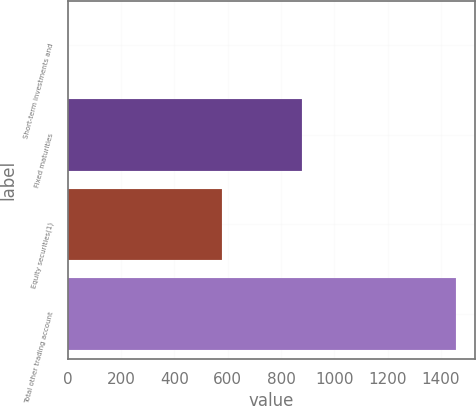<chart> <loc_0><loc_0><loc_500><loc_500><bar_chart><fcel>Short-term investments and<fcel>Fixed maturities<fcel>Equity securities(1)<fcel>Total other trading account<nl><fcel>1<fcel>878<fcel>577<fcel>1456<nl></chart> 